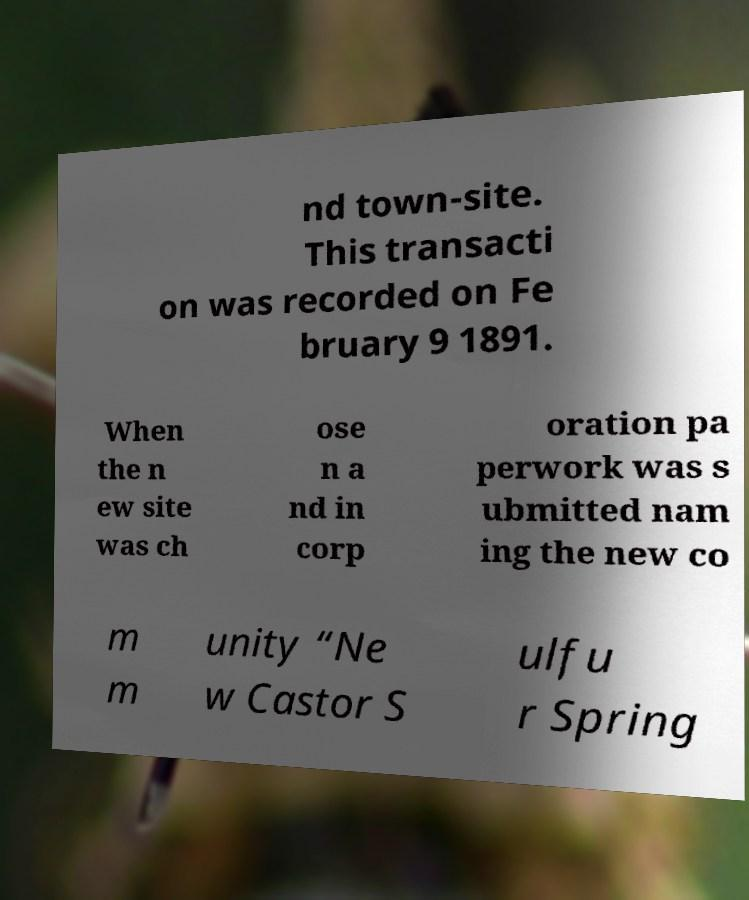Could you extract and type out the text from this image? nd town-site. This transacti on was recorded on Fe bruary 9 1891. When the n ew site was ch ose n a nd in corp oration pa perwork was s ubmitted nam ing the new co m m unity “Ne w Castor S ulfu r Spring 